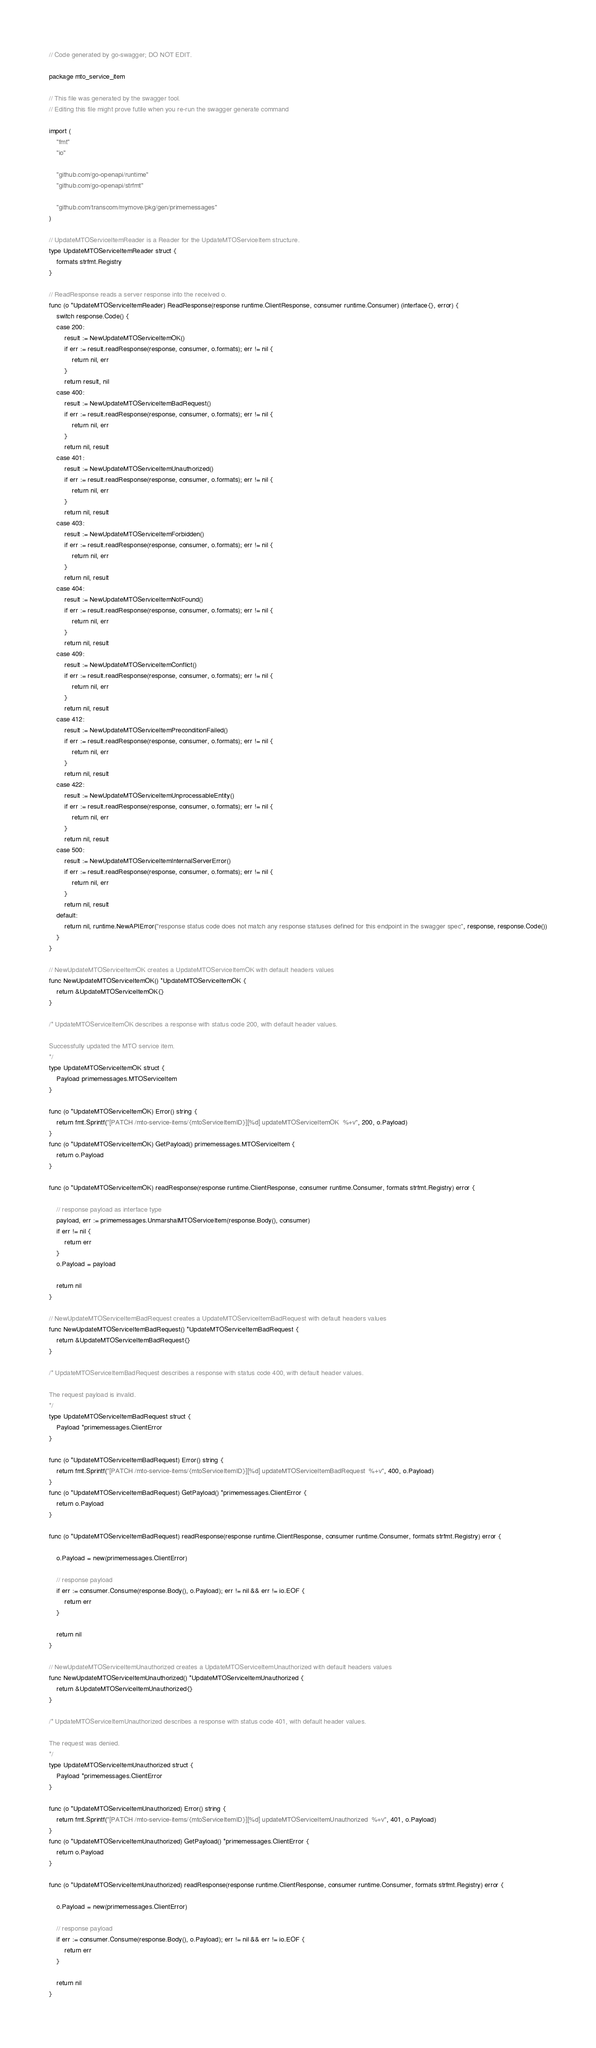Convert code to text. <code><loc_0><loc_0><loc_500><loc_500><_Go_>// Code generated by go-swagger; DO NOT EDIT.

package mto_service_item

// This file was generated by the swagger tool.
// Editing this file might prove futile when you re-run the swagger generate command

import (
	"fmt"
	"io"

	"github.com/go-openapi/runtime"
	"github.com/go-openapi/strfmt"

	"github.com/transcom/mymove/pkg/gen/primemessages"
)

// UpdateMTOServiceItemReader is a Reader for the UpdateMTOServiceItem structure.
type UpdateMTOServiceItemReader struct {
	formats strfmt.Registry
}

// ReadResponse reads a server response into the received o.
func (o *UpdateMTOServiceItemReader) ReadResponse(response runtime.ClientResponse, consumer runtime.Consumer) (interface{}, error) {
	switch response.Code() {
	case 200:
		result := NewUpdateMTOServiceItemOK()
		if err := result.readResponse(response, consumer, o.formats); err != nil {
			return nil, err
		}
		return result, nil
	case 400:
		result := NewUpdateMTOServiceItemBadRequest()
		if err := result.readResponse(response, consumer, o.formats); err != nil {
			return nil, err
		}
		return nil, result
	case 401:
		result := NewUpdateMTOServiceItemUnauthorized()
		if err := result.readResponse(response, consumer, o.formats); err != nil {
			return nil, err
		}
		return nil, result
	case 403:
		result := NewUpdateMTOServiceItemForbidden()
		if err := result.readResponse(response, consumer, o.formats); err != nil {
			return nil, err
		}
		return nil, result
	case 404:
		result := NewUpdateMTOServiceItemNotFound()
		if err := result.readResponse(response, consumer, o.formats); err != nil {
			return nil, err
		}
		return nil, result
	case 409:
		result := NewUpdateMTOServiceItemConflict()
		if err := result.readResponse(response, consumer, o.formats); err != nil {
			return nil, err
		}
		return nil, result
	case 412:
		result := NewUpdateMTOServiceItemPreconditionFailed()
		if err := result.readResponse(response, consumer, o.formats); err != nil {
			return nil, err
		}
		return nil, result
	case 422:
		result := NewUpdateMTOServiceItemUnprocessableEntity()
		if err := result.readResponse(response, consumer, o.formats); err != nil {
			return nil, err
		}
		return nil, result
	case 500:
		result := NewUpdateMTOServiceItemInternalServerError()
		if err := result.readResponse(response, consumer, o.formats); err != nil {
			return nil, err
		}
		return nil, result
	default:
		return nil, runtime.NewAPIError("response status code does not match any response statuses defined for this endpoint in the swagger spec", response, response.Code())
	}
}

// NewUpdateMTOServiceItemOK creates a UpdateMTOServiceItemOK with default headers values
func NewUpdateMTOServiceItemOK() *UpdateMTOServiceItemOK {
	return &UpdateMTOServiceItemOK{}
}

/* UpdateMTOServiceItemOK describes a response with status code 200, with default header values.

Successfully updated the MTO service item.
*/
type UpdateMTOServiceItemOK struct {
	Payload primemessages.MTOServiceItem
}

func (o *UpdateMTOServiceItemOK) Error() string {
	return fmt.Sprintf("[PATCH /mto-service-items/{mtoServiceItemID}][%d] updateMTOServiceItemOK  %+v", 200, o.Payload)
}
func (o *UpdateMTOServiceItemOK) GetPayload() primemessages.MTOServiceItem {
	return o.Payload
}

func (o *UpdateMTOServiceItemOK) readResponse(response runtime.ClientResponse, consumer runtime.Consumer, formats strfmt.Registry) error {

	// response payload as interface type
	payload, err := primemessages.UnmarshalMTOServiceItem(response.Body(), consumer)
	if err != nil {
		return err
	}
	o.Payload = payload

	return nil
}

// NewUpdateMTOServiceItemBadRequest creates a UpdateMTOServiceItemBadRequest with default headers values
func NewUpdateMTOServiceItemBadRequest() *UpdateMTOServiceItemBadRequest {
	return &UpdateMTOServiceItemBadRequest{}
}

/* UpdateMTOServiceItemBadRequest describes a response with status code 400, with default header values.

The request payload is invalid.
*/
type UpdateMTOServiceItemBadRequest struct {
	Payload *primemessages.ClientError
}

func (o *UpdateMTOServiceItemBadRequest) Error() string {
	return fmt.Sprintf("[PATCH /mto-service-items/{mtoServiceItemID}][%d] updateMTOServiceItemBadRequest  %+v", 400, o.Payload)
}
func (o *UpdateMTOServiceItemBadRequest) GetPayload() *primemessages.ClientError {
	return o.Payload
}

func (o *UpdateMTOServiceItemBadRequest) readResponse(response runtime.ClientResponse, consumer runtime.Consumer, formats strfmt.Registry) error {

	o.Payload = new(primemessages.ClientError)

	// response payload
	if err := consumer.Consume(response.Body(), o.Payload); err != nil && err != io.EOF {
		return err
	}

	return nil
}

// NewUpdateMTOServiceItemUnauthorized creates a UpdateMTOServiceItemUnauthorized with default headers values
func NewUpdateMTOServiceItemUnauthorized() *UpdateMTOServiceItemUnauthorized {
	return &UpdateMTOServiceItemUnauthorized{}
}

/* UpdateMTOServiceItemUnauthorized describes a response with status code 401, with default header values.

The request was denied.
*/
type UpdateMTOServiceItemUnauthorized struct {
	Payload *primemessages.ClientError
}

func (o *UpdateMTOServiceItemUnauthorized) Error() string {
	return fmt.Sprintf("[PATCH /mto-service-items/{mtoServiceItemID}][%d] updateMTOServiceItemUnauthorized  %+v", 401, o.Payload)
}
func (o *UpdateMTOServiceItemUnauthorized) GetPayload() *primemessages.ClientError {
	return o.Payload
}

func (o *UpdateMTOServiceItemUnauthorized) readResponse(response runtime.ClientResponse, consumer runtime.Consumer, formats strfmt.Registry) error {

	o.Payload = new(primemessages.ClientError)

	// response payload
	if err := consumer.Consume(response.Body(), o.Payload); err != nil && err != io.EOF {
		return err
	}

	return nil
}
</code> 